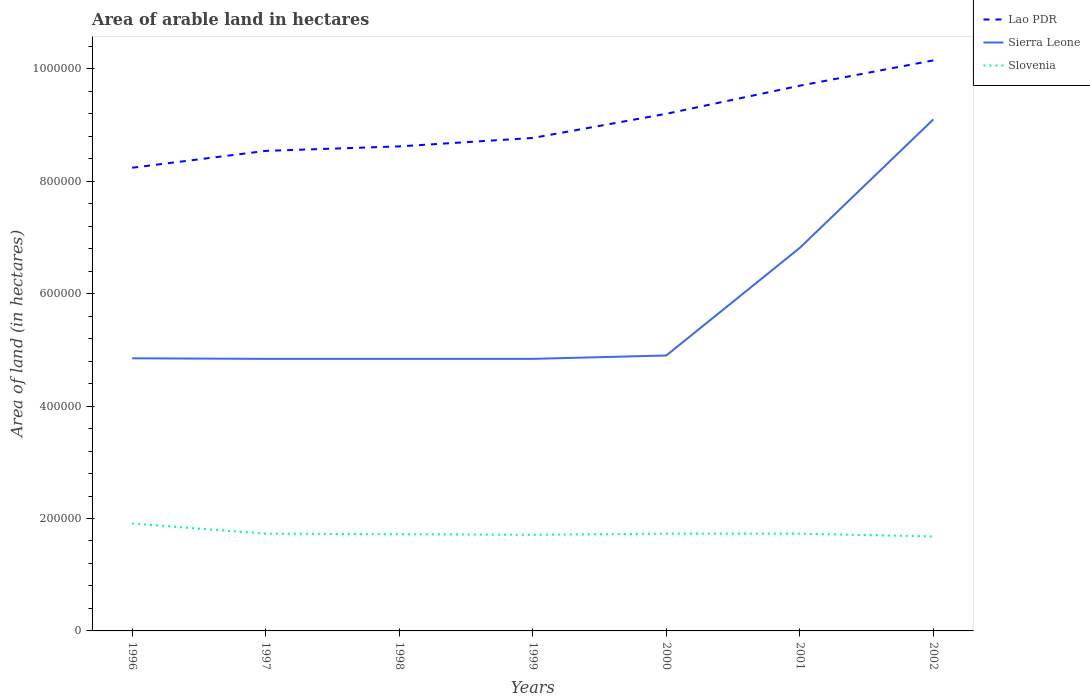Does the line corresponding to Lao PDR intersect with the line corresponding to Sierra Leone?
Offer a very short reply. No. Across all years, what is the maximum total arable land in Lao PDR?
Offer a very short reply. 8.24e+05. What is the total total arable land in Slovenia in the graph?
Ensure brevity in your answer.  -1000. What is the difference between the highest and the second highest total arable land in Slovenia?
Your response must be concise. 2.30e+04. Is the total arable land in Slovenia strictly greater than the total arable land in Lao PDR over the years?
Make the answer very short. Yes. How many years are there in the graph?
Give a very brief answer. 7. What is the difference between two consecutive major ticks on the Y-axis?
Make the answer very short. 2.00e+05. Are the values on the major ticks of Y-axis written in scientific E-notation?
Keep it short and to the point. No. Does the graph contain grids?
Make the answer very short. No. Where does the legend appear in the graph?
Your answer should be compact. Top right. How are the legend labels stacked?
Make the answer very short. Vertical. What is the title of the graph?
Your answer should be very brief. Area of arable land in hectares. What is the label or title of the X-axis?
Your answer should be compact. Years. What is the label or title of the Y-axis?
Your answer should be compact. Area of land (in hectares). What is the Area of land (in hectares) in Lao PDR in 1996?
Offer a very short reply. 8.24e+05. What is the Area of land (in hectares) in Sierra Leone in 1996?
Give a very brief answer. 4.85e+05. What is the Area of land (in hectares) of Slovenia in 1996?
Offer a very short reply. 1.91e+05. What is the Area of land (in hectares) in Lao PDR in 1997?
Keep it short and to the point. 8.54e+05. What is the Area of land (in hectares) of Sierra Leone in 1997?
Keep it short and to the point. 4.84e+05. What is the Area of land (in hectares) in Slovenia in 1997?
Provide a succinct answer. 1.73e+05. What is the Area of land (in hectares) in Lao PDR in 1998?
Provide a succinct answer. 8.62e+05. What is the Area of land (in hectares) of Sierra Leone in 1998?
Ensure brevity in your answer.  4.84e+05. What is the Area of land (in hectares) of Slovenia in 1998?
Offer a terse response. 1.72e+05. What is the Area of land (in hectares) in Lao PDR in 1999?
Keep it short and to the point. 8.77e+05. What is the Area of land (in hectares) of Sierra Leone in 1999?
Make the answer very short. 4.84e+05. What is the Area of land (in hectares) of Slovenia in 1999?
Your answer should be very brief. 1.71e+05. What is the Area of land (in hectares) in Lao PDR in 2000?
Your response must be concise. 9.20e+05. What is the Area of land (in hectares) in Slovenia in 2000?
Make the answer very short. 1.73e+05. What is the Area of land (in hectares) of Lao PDR in 2001?
Your answer should be compact. 9.70e+05. What is the Area of land (in hectares) in Sierra Leone in 2001?
Your answer should be compact. 6.82e+05. What is the Area of land (in hectares) in Slovenia in 2001?
Your response must be concise. 1.73e+05. What is the Area of land (in hectares) of Lao PDR in 2002?
Provide a short and direct response. 1.02e+06. What is the Area of land (in hectares) of Sierra Leone in 2002?
Provide a succinct answer. 9.10e+05. What is the Area of land (in hectares) in Slovenia in 2002?
Your response must be concise. 1.68e+05. Across all years, what is the maximum Area of land (in hectares) of Lao PDR?
Your response must be concise. 1.02e+06. Across all years, what is the maximum Area of land (in hectares) of Sierra Leone?
Keep it short and to the point. 9.10e+05. Across all years, what is the maximum Area of land (in hectares) in Slovenia?
Offer a very short reply. 1.91e+05. Across all years, what is the minimum Area of land (in hectares) in Lao PDR?
Give a very brief answer. 8.24e+05. Across all years, what is the minimum Area of land (in hectares) of Sierra Leone?
Provide a short and direct response. 4.84e+05. Across all years, what is the minimum Area of land (in hectares) in Slovenia?
Your answer should be compact. 1.68e+05. What is the total Area of land (in hectares) of Lao PDR in the graph?
Provide a succinct answer. 6.32e+06. What is the total Area of land (in hectares) of Sierra Leone in the graph?
Provide a succinct answer. 4.02e+06. What is the total Area of land (in hectares) in Slovenia in the graph?
Give a very brief answer. 1.22e+06. What is the difference between the Area of land (in hectares) of Lao PDR in 1996 and that in 1997?
Ensure brevity in your answer.  -3.00e+04. What is the difference between the Area of land (in hectares) in Slovenia in 1996 and that in 1997?
Keep it short and to the point. 1.80e+04. What is the difference between the Area of land (in hectares) in Lao PDR in 1996 and that in 1998?
Provide a short and direct response. -3.80e+04. What is the difference between the Area of land (in hectares) of Slovenia in 1996 and that in 1998?
Ensure brevity in your answer.  1.90e+04. What is the difference between the Area of land (in hectares) in Lao PDR in 1996 and that in 1999?
Give a very brief answer. -5.30e+04. What is the difference between the Area of land (in hectares) in Slovenia in 1996 and that in 1999?
Keep it short and to the point. 2.00e+04. What is the difference between the Area of land (in hectares) of Lao PDR in 1996 and that in 2000?
Offer a terse response. -9.60e+04. What is the difference between the Area of land (in hectares) of Sierra Leone in 1996 and that in 2000?
Your answer should be compact. -5000. What is the difference between the Area of land (in hectares) in Slovenia in 1996 and that in 2000?
Offer a terse response. 1.80e+04. What is the difference between the Area of land (in hectares) of Lao PDR in 1996 and that in 2001?
Provide a short and direct response. -1.46e+05. What is the difference between the Area of land (in hectares) of Sierra Leone in 1996 and that in 2001?
Offer a terse response. -1.97e+05. What is the difference between the Area of land (in hectares) in Slovenia in 1996 and that in 2001?
Provide a succinct answer. 1.80e+04. What is the difference between the Area of land (in hectares) of Lao PDR in 1996 and that in 2002?
Provide a short and direct response. -1.91e+05. What is the difference between the Area of land (in hectares) in Sierra Leone in 1996 and that in 2002?
Make the answer very short. -4.25e+05. What is the difference between the Area of land (in hectares) of Slovenia in 1996 and that in 2002?
Keep it short and to the point. 2.30e+04. What is the difference between the Area of land (in hectares) in Lao PDR in 1997 and that in 1998?
Give a very brief answer. -8000. What is the difference between the Area of land (in hectares) of Sierra Leone in 1997 and that in 1998?
Offer a very short reply. 0. What is the difference between the Area of land (in hectares) in Lao PDR in 1997 and that in 1999?
Provide a short and direct response. -2.30e+04. What is the difference between the Area of land (in hectares) of Slovenia in 1997 and that in 1999?
Provide a succinct answer. 2000. What is the difference between the Area of land (in hectares) in Lao PDR in 1997 and that in 2000?
Your answer should be very brief. -6.60e+04. What is the difference between the Area of land (in hectares) of Sierra Leone in 1997 and that in 2000?
Your answer should be very brief. -6000. What is the difference between the Area of land (in hectares) in Lao PDR in 1997 and that in 2001?
Give a very brief answer. -1.16e+05. What is the difference between the Area of land (in hectares) in Sierra Leone in 1997 and that in 2001?
Your answer should be compact. -1.98e+05. What is the difference between the Area of land (in hectares) of Lao PDR in 1997 and that in 2002?
Offer a terse response. -1.61e+05. What is the difference between the Area of land (in hectares) of Sierra Leone in 1997 and that in 2002?
Ensure brevity in your answer.  -4.26e+05. What is the difference between the Area of land (in hectares) of Lao PDR in 1998 and that in 1999?
Give a very brief answer. -1.50e+04. What is the difference between the Area of land (in hectares) in Lao PDR in 1998 and that in 2000?
Give a very brief answer. -5.80e+04. What is the difference between the Area of land (in hectares) of Sierra Leone in 1998 and that in 2000?
Keep it short and to the point. -6000. What is the difference between the Area of land (in hectares) of Slovenia in 1998 and that in 2000?
Ensure brevity in your answer.  -1000. What is the difference between the Area of land (in hectares) in Lao PDR in 1998 and that in 2001?
Your answer should be compact. -1.08e+05. What is the difference between the Area of land (in hectares) in Sierra Leone in 1998 and that in 2001?
Keep it short and to the point. -1.98e+05. What is the difference between the Area of land (in hectares) in Slovenia in 1998 and that in 2001?
Your answer should be compact. -1000. What is the difference between the Area of land (in hectares) in Lao PDR in 1998 and that in 2002?
Your response must be concise. -1.53e+05. What is the difference between the Area of land (in hectares) of Sierra Leone in 1998 and that in 2002?
Provide a succinct answer. -4.26e+05. What is the difference between the Area of land (in hectares) of Slovenia in 1998 and that in 2002?
Give a very brief answer. 4000. What is the difference between the Area of land (in hectares) of Lao PDR in 1999 and that in 2000?
Offer a very short reply. -4.30e+04. What is the difference between the Area of land (in hectares) of Sierra Leone in 1999 and that in 2000?
Offer a very short reply. -6000. What is the difference between the Area of land (in hectares) of Slovenia in 1999 and that in 2000?
Give a very brief answer. -2000. What is the difference between the Area of land (in hectares) in Lao PDR in 1999 and that in 2001?
Your answer should be very brief. -9.30e+04. What is the difference between the Area of land (in hectares) of Sierra Leone in 1999 and that in 2001?
Offer a terse response. -1.98e+05. What is the difference between the Area of land (in hectares) in Slovenia in 1999 and that in 2001?
Keep it short and to the point. -2000. What is the difference between the Area of land (in hectares) in Lao PDR in 1999 and that in 2002?
Offer a very short reply. -1.38e+05. What is the difference between the Area of land (in hectares) of Sierra Leone in 1999 and that in 2002?
Offer a very short reply. -4.26e+05. What is the difference between the Area of land (in hectares) in Slovenia in 1999 and that in 2002?
Ensure brevity in your answer.  3000. What is the difference between the Area of land (in hectares) of Sierra Leone in 2000 and that in 2001?
Your answer should be compact. -1.92e+05. What is the difference between the Area of land (in hectares) of Slovenia in 2000 and that in 2001?
Provide a succinct answer. 0. What is the difference between the Area of land (in hectares) in Lao PDR in 2000 and that in 2002?
Your answer should be compact. -9.50e+04. What is the difference between the Area of land (in hectares) of Sierra Leone in 2000 and that in 2002?
Keep it short and to the point. -4.20e+05. What is the difference between the Area of land (in hectares) of Slovenia in 2000 and that in 2002?
Keep it short and to the point. 5000. What is the difference between the Area of land (in hectares) in Lao PDR in 2001 and that in 2002?
Your response must be concise. -4.50e+04. What is the difference between the Area of land (in hectares) in Sierra Leone in 2001 and that in 2002?
Keep it short and to the point. -2.29e+05. What is the difference between the Area of land (in hectares) in Lao PDR in 1996 and the Area of land (in hectares) in Slovenia in 1997?
Give a very brief answer. 6.51e+05. What is the difference between the Area of land (in hectares) in Sierra Leone in 1996 and the Area of land (in hectares) in Slovenia in 1997?
Your answer should be compact. 3.12e+05. What is the difference between the Area of land (in hectares) in Lao PDR in 1996 and the Area of land (in hectares) in Sierra Leone in 1998?
Make the answer very short. 3.40e+05. What is the difference between the Area of land (in hectares) in Lao PDR in 1996 and the Area of land (in hectares) in Slovenia in 1998?
Give a very brief answer. 6.52e+05. What is the difference between the Area of land (in hectares) in Sierra Leone in 1996 and the Area of land (in hectares) in Slovenia in 1998?
Offer a terse response. 3.13e+05. What is the difference between the Area of land (in hectares) of Lao PDR in 1996 and the Area of land (in hectares) of Sierra Leone in 1999?
Ensure brevity in your answer.  3.40e+05. What is the difference between the Area of land (in hectares) in Lao PDR in 1996 and the Area of land (in hectares) in Slovenia in 1999?
Offer a terse response. 6.53e+05. What is the difference between the Area of land (in hectares) of Sierra Leone in 1996 and the Area of land (in hectares) of Slovenia in 1999?
Give a very brief answer. 3.14e+05. What is the difference between the Area of land (in hectares) of Lao PDR in 1996 and the Area of land (in hectares) of Sierra Leone in 2000?
Your answer should be compact. 3.34e+05. What is the difference between the Area of land (in hectares) in Lao PDR in 1996 and the Area of land (in hectares) in Slovenia in 2000?
Offer a terse response. 6.51e+05. What is the difference between the Area of land (in hectares) in Sierra Leone in 1996 and the Area of land (in hectares) in Slovenia in 2000?
Provide a succinct answer. 3.12e+05. What is the difference between the Area of land (in hectares) in Lao PDR in 1996 and the Area of land (in hectares) in Sierra Leone in 2001?
Offer a very short reply. 1.42e+05. What is the difference between the Area of land (in hectares) of Lao PDR in 1996 and the Area of land (in hectares) of Slovenia in 2001?
Offer a terse response. 6.51e+05. What is the difference between the Area of land (in hectares) in Sierra Leone in 1996 and the Area of land (in hectares) in Slovenia in 2001?
Your answer should be compact. 3.12e+05. What is the difference between the Area of land (in hectares) of Lao PDR in 1996 and the Area of land (in hectares) of Sierra Leone in 2002?
Offer a very short reply. -8.61e+04. What is the difference between the Area of land (in hectares) in Lao PDR in 1996 and the Area of land (in hectares) in Slovenia in 2002?
Provide a short and direct response. 6.56e+05. What is the difference between the Area of land (in hectares) of Sierra Leone in 1996 and the Area of land (in hectares) of Slovenia in 2002?
Provide a succinct answer. 3.17e+05. What is the difference between the Area of land (in hectares) of Lao PDR in 1997 and the Area of land (in hectares) of Slovenia in 1998?
Your answer should be very brief. 6.82e+05. What is the difference between the Area of land (in hectares) in Sierra Leone in 1997 and the Area of land (in hectares) in Slovenia in 1998?
Provide a succinct answer. 3.12e+05. What is the difference between the Area of land (in hectares) of Lao PDR in 1997 and the Area of land (in hectares) of Sierra Leone in 1999?
Your answer should be compact. 3.70e+05. What is the difference between the Area of land (in hectares) in Lao PDR in 1997 and the Area of land (in hectares) in Slovenia in 1999?
Your answer should be very brief. 6.83e+05. What is the difference between the Area of land (in hectares) of Sierra Leone in 1997 and the Area of land (in hectares) of Slovenia in 1999?
Give a very brief answer. 3.13e+05. What is the difference between the Area of land (in hectares) in Lao PDR in 1997 and the Area of land (in hectares) in Sierra Leone in 2000?
Give a very brief answer. 3.64e+05. What is the difference between the Area of land (in hectares) in Lao PDR in 1997 and the Area of land (in hectares) in Slovenia in 2000?
Provide a short and direct response. 6.81e+05. What is the difference between the Area of land (in hectares) in Sierra Leone in 1997 and the Area of land (in hectares) in Slovenia in 2000?
Provide a short and direct response. 3.11e+05. What is the difference between the Area of land (in hectares) of Lao PDR in 1997 and the Area of land (in hectares) of Sierra Leone in 2001?
Keep it short and to the point. 1.72e+05. What is the difference between the Area of land (in hectares) in Lao PDR in 1997 and the Area of land (in hectares) in Slovenia in 2001?
Make the answer very short. 6.81e+05. What is the difference between the Area of land (in hectares) in Sierra Leone in 1997 and the Area of land (in hectares) in Slovenia in 2001?
Offer a terse response. 3.11e+05. What is the difference between the Area of land (in hectares) of Lao PDR in 1997 and the Area of land (in hectares) of Sierra Leone in 2002?
Offer a terse response. -5.61e+04. What is the difference between the Area of land (in hectares) of Lao PDR in 1997 and the Area of land (in hectares) of Slovenia in 2002?
Give a very brief answer. 6.86e+05. What is the difference between the Area of land (in hectares) in Sierra Leone in 1997 and the Area of land (in hectares) in Slovenia in 2002?
Keep it short and to the point. 3.16e+05. What is the difference between the Area of land (in hectares) in Lao PDR in 1998 and the Area of land (in hectares) in Sierra Leone in 1999?
Offer a terse response. 3.78e+05. What is the difference between the Area of land (in hectares) of Lao PDR in 1998 and the Area of land (in hectares) of Slovenia in 1999?
Ensure brevity in your answer.  6.91e+05. What is the difference between the Area of land (in hectares) of Sierra Leone in 1998 and the Area of land (in hectares) of Slovenia in 1999?
Ensure brevity in your answer.  3.13e+05. What is the difference between the Area of land (in hectares) of Lao PDR in 1998 and the Area of land (in hectares) of Sierra Leone in 2000?
Your answer should be compact. 3.72e+05. What is the difference between the Area of land (in hectares) of Lao PDR in 1998 and the Area of land (in hectares) of Slovenia in 2000?
Ensure brevity in your answer.  6.89e+05. What is the difference between the Area of land (in hectares) in Sierra Leone in 1998 and the Area of land (in hectares) in Slovenia in 2000?
Ensure brevity in your answer.  3.11e+05. What is the difference between the Area of land (in hectares) of Lao PDR in 1998 and the Area of land (in hectares) of Sierra Leone in 2001?
Ensure brevity in your answer.  1.80e+05. What is the difference between the Area of land (in hectares) in Lao PDR in 1998 and the Area of land (in hectares) in Slovenia in 2001?
Your response must be concise. 6.89e+05. What is the difference between the Area of land (in hectares) in Sierra Leone in 1998 and the Area of land (in hectares) in Slovenia in 2001?
Your answer should be very brief. 3.11e+05. What is the difference between the Area of land (in hectares) of Lao PDR in 1998 and the Area of land (in hectares) of Sierra Leone in 2002?
Your answer should be very brief. -4.81e+04. What is the difference between the Area of land (in hectares) of Lao PDR in 1998 and the Area of land (in hectares) of Slovenia in 2002?
Make the answer very short. 6.94e+05. What is the difference between the Area of land (in hectares) in Sierra Leone in 1998 and the Area of land (in hectares) in Slovenia in 2002?
Provide a short and direct response. 3.16e+05. What is the difference between the Area of land (in hectares) in Lao PDR in 1999 and the Area of land (in hectares) in Sierra Leone in 2000?
Your answer should be very brief. 3.87e+05. What is the difference between the Area of land (in hectares) of Lao PDR in 1999 and the Area of land (in hectares) of Slovenia in 2000?
Your response must be concise. 7.04e+05. What is the difference between the Area of land (in hectares) in Sierra Leone in 1999 and the Area of land (in hectares) in Slovenia in 2000?
Your answer should be very brief. 3.11e+05. What is the difference between the Area of land (in hectares) of Lao PDR in 1999 and the Area of land (in hectares) of Sierra Leone in 2001?
Provide a succinct answer. 1.95e+05. What is the difference between the Area of land (in hectares) of Lao PDR in 1999 and the Area of land (in hectares) of Slovenia in 2001?
Offer a terse response. 7.04e+05. What is the difference between the Area of land (in hectares) in Sierra Leone in 1999 and the Area of land (in hectares) in Slovenia in 2001?
Ensure brevity in your answer.  3.11e+05. What is the difference between the Area of land (in hectares) of Lao PDR in 1999 and the Area of land (in hectares) of Sierra Leone in 2002?
Provide a short and direct response. -3.31e+04. What is the difference between the Area of land (in hectares) of Lao PDR in 1999 and the Area of land (in hectares) of Slovenia in 2002?
Your answer should be compact. 7.09e+05. What is the difference between the Area of land (in hectares) in Sierra Leone in 1999 and the Area of land (in hectares) in Slovenia in 2002?
Your answer should be very brief. 3.16e+05. What is the difference between the Area of land (in hectares) of Lao PDR in 2000 and the Area of land (in hectares) of Sierra Leone in 2001?
Give a very brief answer. 2.38e+05. What is the difference between the Area of land (in hectares) in Lao PDR in 2000 and the Area of land (in hectares) in Slovenia in 2001?
Provide a short and direct response. 7.47e+05. What is the difference between the Area of land (in hectares) of Sierra Leone in 2000 and the Area of land (in hectares) of Slovenia in 2001?
Make the answer very short. 3.17e+05. What is the difference between the Area of land (in hectares) in Lao PDR in 2000 and the Area of land (in hectares) in Sierra Leone in 2002?
Keep it short and to the point. 9920. What is the difference between the Area of land (in hectares) in Lao PDR in 2000 and the Area of land (in hectares) in Slovenia in 2002?
Offer a terse response. 7.52e+05. What is the difference between the Area of land (in hectares) of Sierra Leone in 2000 and the Area of land (in hectares) of Slovenia in 2002?
Give a very brief answer. 3.22e+05. What is the difference between the Area of land (in hectares) in Lao PDR in 2001 and the Area of land (in hectares) in Sierra Leone in 2002?
Your answer should be compact. 5.99e+04. What is the difference between the Area of land (in hectares) of Lao PDR in 2001 and the Area of land (in hectares) of Slovenia in 2002?
Provide a succinct answer. 8.02e+05. What is the difference between the Area of land (in hectares) in Sierra Leone in 2001 and the Area of land (in hectares) in Slovenia in 2002?
Ensure brevity in your answer.  5.14e+05. What is the average Area of land (in hectares) in Lao PDR per year?
Your response must be concise. 9.03e+05. What is the average Area of land (in hectares) in Sierra Leone per year?
Your answer should be compact. 5.74e+05. What is the average Area of land (in hectares) in Slovenia per year?
Give a very brief answer. 1.74e+05. In the year 1996, what is the difference between the Area of land (in hectares) in Lao PDR and Area of land (in hectares) in Sierra Leone?
Make the answer very short. 3.39e+05. In the year 1996, what is the difference between the Area of land (in hectares) in Lao PDR and Area of land (in hectares) in Slovenia?
Your answer should be very brief. 6.33e+05. In the year 1996, what is the difference between the Area of land (in hectares) of Sierra Leone and Area of land (in hectares) of Slovenia?
Your answer should be very brief. 2.94e+05. In the year 1997, what is the difference between the Area of land (in hectares) of Lao PDR and Area of land (in hectares) of Slovenia?
Give a very brief answer. 6.81e+05. In the year 1997, what is the difference between the Area of land (in hectares) in Sierra Leone and Area of land (in hectares) in Slovenia?
Keep it short and to the point. 3.11e+05. In the year 1998, what is the difference between the Area of land (in hectares) of Lao PDR and Area of land (in hectares) of Sierra Leone?
Your answer should be very brief. 3.78e+05. In the year 1998, what is the difference between the Area of land (in hectares) in Lao PDR and Area of land (in hectares) in Slovenia?
Provide a short and direct response. 6.90e+05. In the year 1998, what is the difference between the Area of land (in hectares) in Sierra Leone and Area of land (in hectares) in Slovenia?
Provide a succinct answer. 3.12e+05. In the year 1999, what is the difference between the Area of land (in hectares) of Lao PDR and Area of land (in hectares) of Sierra Leone?
Your answer should be very brief. 3.93e+05. In the year 1999, what is the difference between the Area of land (in hectares) in Lao PDR and Area of land (in hectares) in Slovenia?
Provide a short and direct response. 7.06e+05. In the year 1999, what is the difference between the Area of land (in hectares) in Sierra Leone and Area of land (in hectares) in Slovenia?
Offer a terse response. 3.13e+05. In the year 2000, what is the difference between the Area of land (in hectares) in Lao PDR and Area of land (in hectares) in Slovenia?
Make the answer very short. 7.47e+05. In the year 2000, what is the difference between the Area of land (in hectares) of Sierra Leone and Area of land (in hectares) of Slovenia?
Offer a terse response. 3.17e+05. In the year 2001, what is the difference between the Area of land (in hectares) of Lao PDR and Area of land (in hectares) of Sierra Leone?
Offer a very short reply. 2.88e+05. In the year 2001, what is the difference between the Area of land (in hectares) in Lao PDR and Area of land (in hectares) in Slovenia?
Your answer should be very brief. 7.97e+05. In the year 2001, what is the difference between the Area of land (in hectares) in Sierra Leone and Area of land (in hectares) in Slovenia?
Offer a very short reply. 5.09e+05. In the year 2002, what is the difference between the Area of land (in hectares) of Lao PDR and Area of land (in hectares) of Sierra Leone?
Offer a terse response. 1.05e+05. In the year 2002, what is the difference between the Area of land (in hectares) of Lao PDR and Area of land (in hectares) of Slovenia?
Give a very brief answer. 8.47e+05. In the year 2002, what is the difference between the Area of land (in hectares) of Sierra Leone and Area of land (in hectares) of Slovenia?
Make the answer very short. 7.42e+05. What is the ratio of the Area of land (in hectares) in Lao PDR in 1996 to that in 1997?
Give a very brief answer. 0.96. What is the ratio of the Area of land (in hectares) of Sierra Leone in 1996 to that in 1997?
Your answer should be very brief. 1. What is the ratio of the Area of land (in hectares) of Slovenia in 1996 to that in 1997?
Provide a succinct answer. 1.1. What is the ratio of the Area of land (in hectares) in Lao PDR in 1996 to that in 1998?
Your answer should be compact. 0.96. What is the ratio of the Area of land (in hectares) of Sierra Leone in 1996 to that in 1998?
Your response must be concise. 1. What is the ratio of the Area of land (in hectares) in Slovenia in 1996 to that in 1998?
Give a very brief answer. 1.11. What is the ratio of the Area of land (in hectares) in Lao PDR in 1996 to that in 1999?
Keep it short and to the point. 0.94. What is the ratio of the Area of land (in hectares) in Sierra Leone in 1996 to that in 1999?
Offer a very short reply. 1. What is the ratio of the Area of land (in hectares) in Slovenia in 1996 to that in 1999?
Offer a terse response. 1.12. What is the ratio of the Area of land (in hectares) in Lao PDR in 1996 to that in 2000?
Provide a short and direct response. 0.9. What is the ratio of the Area of land (in hectares) of Sierra Leone in 1996 to that in 2000?
Keep it short and to the point. 0.99. What is the ratio of the Area of land (in hectares) of Slovenia in 1996 to that in 2000?
Give a very brief answer. 1.1. What is the ratio of the Area of land (in hectares) in Lao PDR in 1996 to that in 2001?
Ensure brevity in your answer.  0.85. What is the ratio of the Area of land (in hectares) in Sierra Leone in 1996 to that in 2001?
Your response must be concise. 0.71. What is the ratio of the Area of land (in hectares) in Slovenia in 1996 to that in 2001?
Give a very brief answer. 1.1. What is the ratio of the Area of land (in hectares) of Lao PDR in 1996 to that in 2002?
Keep it short and to the point. 0.81. What is the ratio of the Area of land (in hectares) of Sierra Leone in 1996 to that in 2002?
Provide a succinct answer. 0.53. What is the ratio of the Area of land (in hectares) of Slovenia in 1996 to that in 2002?
Make the answer very short. 1.14. What is the ratio of the Area of land (in hectares) of Sierra Leone in 1997 to that in 1998?
Ensure brevity in your answer.  1. What is the ratio of the Area of land (in hectares) of Lao PDR in 1997 to that in 1999?
Keep it short and to the point. 0.97. What is the ratio of the Area of land (in hectares) in Slovenia in 1997 to that in 1999?
Make the answer very short. 1.01. What is the ratio of the Area of land (in hectares) in Lao PDR in 1997 to that in 2000?
Give a very brief answer. 0.93. What is the ratio of the Area of land (in hectares) in Sierra Leone in 1997 to that in 2000?
Provide a succinct answer. 0.99. What is the ratio of the Area of land (in hectares) of Lao PDR in 1997 to that in 2001?
Keep it short and to the point. 0.88. What is the ratio of the Area of land (in hectares) of Sierra Leone in 1997 to that in 2001?
Make the answer very short. 0.71. What is the ratio of the Area of land (in hectares) in Slovenia in 1997 to that in 2001?
Make the answer very short. 1. What is the ratio of the Area of land (in hectares) in Lao PDR in 1997 to that in 2002?
Your response must be concise. 0.84. What is the ratio of the Area of land (in hectares) in Sierra Leone in 1997 to that in 2002?
Keep it short and to the point. 0.53. What is the ratio of the Area of land (in hectares) in Slovenia in 1997 to that in 2002?
Your answer should be compact. 1.03. What is the ratio of the Area of land (in hectares) in Lao PDR in 1998 to that in 1999?
Your answer should be compact. 0.98. What is the ratio of the Area of land (in hectares) in Sierra Leone in 1998 to that in 1999?
Ensure brevity in your answer.  1. What is the ratio of the Area of land (in hectares) of Lao PDR in 1998 to that in 2000?
Your answer should be compact. 0.94. What is the ratio of the Area of land (in hectares) in Lao PDR in 1998 to that in 2001?
Ensure brevity in your answer.  0.89. What is the ratio of the Area of land (in hectares) in Sierra Leone in 1998 to that in 2001?
Ensure brevity in your answer.  0.71. What is the ratio of the Area of land (in hectares) in Lao PDR in 1998 to that in 2002?
Your answer should be very brief. 0.85. What is the ratio of the Area of land (in hectares) of Sierra Leone in 1998 to that in 2002?
Provide a short and direct response. 0.53. What is the ratio of the Area of land (in hectares) in Slovenia in 1998 to that in 2002?
Offer a very short reply. 1.02. What is the ratio of the Area of land (in hectares) in Lao PDR in 1999 to that in 2000?
Provide a short and direct response. 0.95. What is the ratio of the Area of land (in hectares) in Sierra Leone in 1999 to that in 2000?
Provide a succinct answer. 0.99. What is the ratio of the Area of land (in hectares) of Slovenia in 1999 to that in 2000?
Provide a short and direct response. 0.99. What is the ratio of the Area of land (in hectares) of Lao PDR in 1999 to that in 2001?
Your response must be concise. 0.9. What is the ratio of the Area of land (in hectares) in Sierra Leone in 1999 to that in 2001?
Offer a very short reply. 0.71. What is the ratio of the Area of land (in hectares) of Slovenia in 1999 to that in 2001?
Keep it short and to the point. 0.99. What is the ratio of the Area of land (in hectares) in Lao PDR in 1999 to that in 2002?
Your answer should be compact. 0.86. What is the ratio of the Area of land (in hectares) of Sierra Leone in 1999 to that in 2002?
Your answer should be compact. 0.53. What is the ratio of the Area of land (in hectares) of Slovenia in 1999 to that in 2002?
Offer a terse response. 1.02. What is the ratio of the Area of land (in hectares) of Lao PDR in 2000 to that in 2001?
Offer a very short reply. 0.95. What is the ratio of the Area of land (in hectares) of Sierra Leone in 2000 to that in 2001?
Make the answer very short. 0.72. What is the ratio of the Area of land (in hectares) in Lao PDR in 2000 to that in 2002?
Give a very brief answer. 0.91. What is the ratio of the Area of land (in hectares) in Sierra Leone in 2000 to that in 2002?
Offer a terse response. 0.54. What is the ratio of the Area of land (in hectares) of Slovenia in 2000 to that in 2002?
Make the answer very short. 1.03. What is the ratio of the Area of land (in hectares) in Lao PDR in 2001 to that in 2002?
Your response must be concise. 0.96. What is the ratio of the Area of land (in hectares) of Sierra Leone in 2001 to that in 2002?
Provide a short and direct response. 0.75. What is the ratio of the Area of land (in hectares) of Slovenia in 2001 to that in 2002?
Keep it short and to the point. 1.03. What is the difference between the highest and the second highest Area of land (in hectares) in Lao PDR?
Offer a terse response. 4.50e+04. What is the difference between the highest and the second highest Area of land (in hectares) of Sierra Leone?
Keep it short and to the point. 2.29e+05. What is the difference between the highest and the second highest Area of land (in hectares) in Slovenia?
Offer a terse response. 1.80e+04. What is the difference between the highest and the lowest Area of land (in hectares) of Lao PDR?
Provide a succinct answer. 1.91e+05. What is the difference between the highest and the lowest Area of land (in hectares) of Sierra Leone?
Provide a succinct answer. 4.26e+05. What is the difference between the highest and the lowest Area of land (in hectares) in Slovenia?
Give a very brief answer. 2.30e+04. 